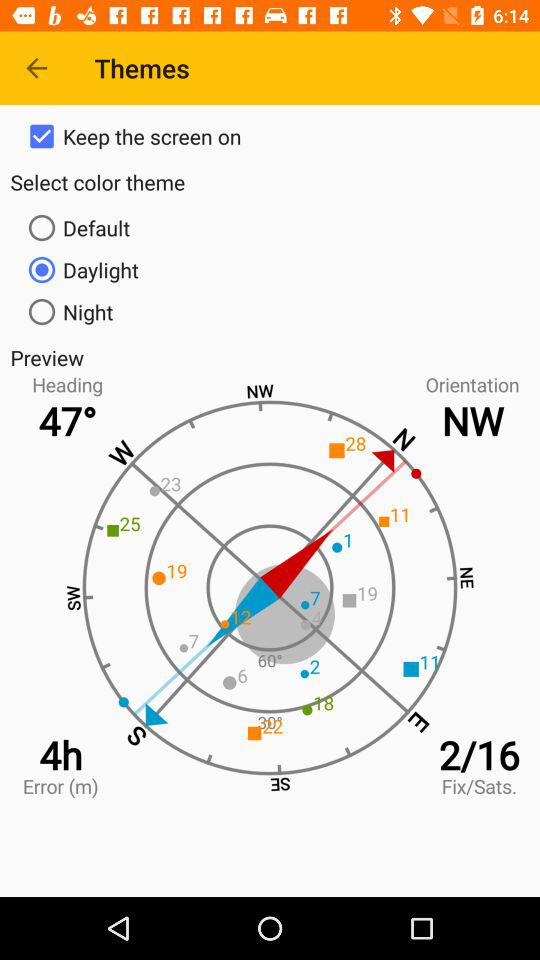Who is this application powered by?
When the provided information is insufficient, respond with <no answer>. <no answer> 